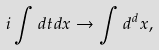Convert formula to latex. <formula><loc_0><loc_0><loc_500><loc_500>i \int d t d { x } \rightarrow \int d ^ { d } x ,</formula> 